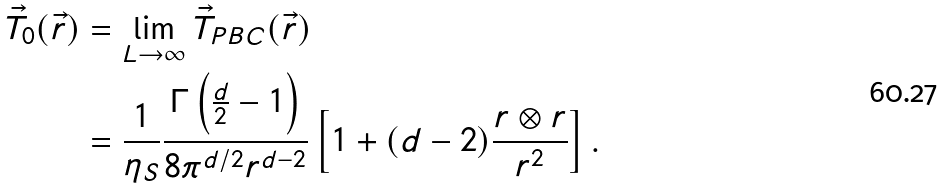Convert formula to latex. <formula><loc_0><loc_0><loc_500><loc_500>\vec { T } _ { 0 } ( \vec { r } ) & = \lim _ { L \to \infty } \vec { T } _ { P B C } ( \vec { r } ) \\ & = \frac { 1 } { \eta _ { S } } \frac { \Gamma \left ( \frac { d } { 2 } - 1 \right ) } { 8 \pi ^ { d / 2 } r ^ { d - 2 } } \left [ 1 + ( d - 2 ) \frac { r \otimes r } { r ^ { 2 } } \right ] .</formula> 